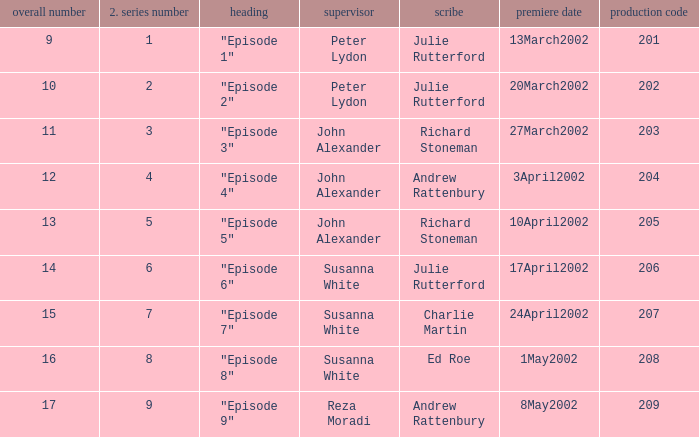When 15 is the number overall what is the original air date? 24April2002. 